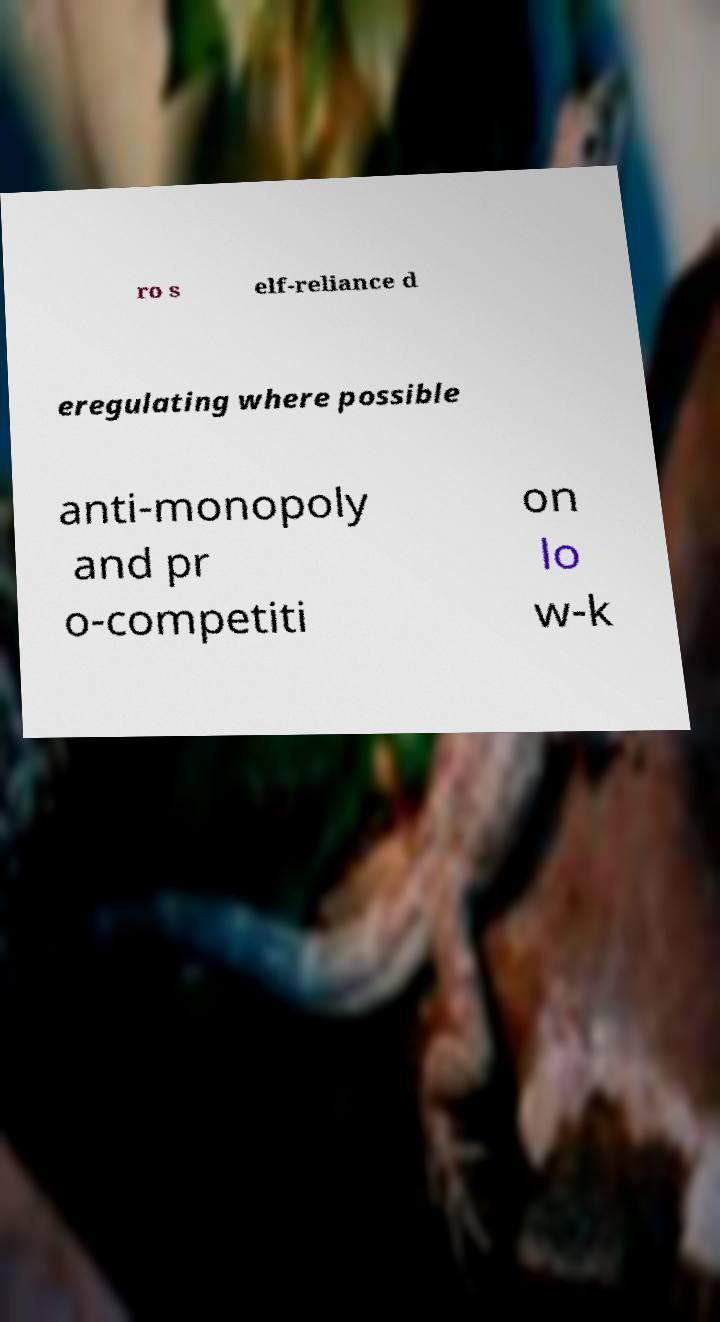Could you extract and type out the text from this image? ro s elf-reliance d eregulating where possible anti-monopoly and pr o-competiti on lo w-k 